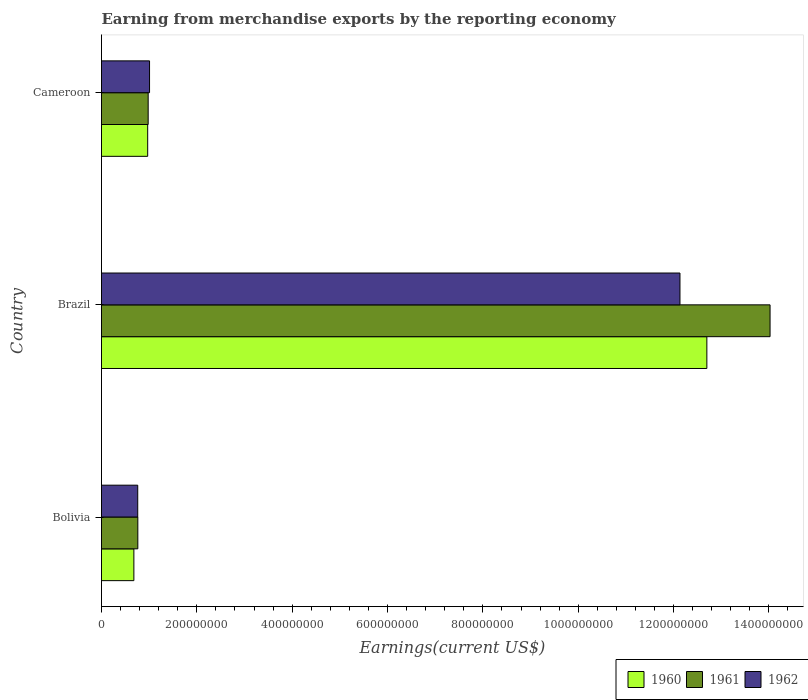How many different coloured bars are there?
Ensure brevity in your answer.  3. Are the number of bars on each tick of the Y-axis equal?
Offer a very short reply. Yes. How many bars are there on the 1st tick from the top?
Your answer should be compact. 3. What is the amount earned from merchandise exports in 1960 in Brazil?
Offer a very short reply. 1.27e+09. Across all countries, what is the maximum amount earned from merchandise exports in 1962?
Your response must be concise. 1.21e+09. Across all countries, what is the minimum amount earned from merchandise exports in 1962?
Give a very brief answer. 7.60e+07. What is the total amount earned from merchandise exports in 1961 in the graph?
Make the answer very short. 1.58e+09. What is the difference between the amount earned from merchandise exports in 1961 in Bolivia and that in Cameroon?
Your answer should be compact. -2.17e+07. What is the difference between the amount earned from merchandise exports in 1962 in Bolivia and the amount earned from merchandise exports in 1960 in Brazil?
Keep it short and to the point. -1.19e+09. What is the average amount earned from merchandise exports in 1960 per country?
Keep it short and to the point. 4.78e+08. What is the difference between the amount earned from merchandise exports in 1961 and amount earned from merchandise exports in 1960 in Brazil?
Keep it short and to the point. 1.33e+08. In how many countries, is the amount earned from merchandise exports in 1961 greater than 120000000 US$?
Offer a terse response. 1. What is the ratio of the amount earned from merchandise exports in 1960 in Brazil to that in Cameroon?
Keep it short and to the point. 13.11. Is the difference between the amount earned from merchandise exports in 1961 in Brazil and Cameroon greater than the difference between the amount earned from merchandise exports in 1960 in Brazil and Cameroon?
Provide a short and direct response. Yes. What is the difference between the highest and the second highest amount earned from merchandise exports in 1961?
Make the answer very short. 1.30e+09. What is the difference between the highest and the lowest amount earned from merchandise exports in 1961?
Provide a short and direct response. 1.33e+09. What does the 1st bar from the bottom in Bolivia represents?
Your answer should be compact. 1960. Is it the case that in every country, the sum of the amount earned from merchandise exports in 1960 and amount earned from merchandise exports in 1961 is greater than the amount earned from merchandise exports in 1962?
Offer a very short reply. Yes. Are the values on the major ticks of X-axis written in scientific E-notation?
Provide a short and direct response. No. Does the graph contain grids?
Ensure brevity in your answer.  No. Where does the legend appear in the graph?
Your response must be concise. Bottom right. How many legend labels are there?
Your response must be concise. 3. What is the title of the graph?
Ensure brevity in your answer.  Earning from merchandise exports by the reporting economy. What is the label or title of the X-axis?
Provide a succinct answer. Earnings(current US$). What is the label or title of the Y-axis?
Provide a succinct answer. Country. What is the Earnings(current US$) in 1960 in Bolivia?
Make the answer very short. 6.79e+07. What is the Earnings(current US$) of 1961 in Bolivia?
Keep it short and to the point. 7.62e+07. What is the Earnings(current US$) in 1962 in Bolivia?
Ensure brevity in your answer.  7.60e+07. What is the Earnings(current US$) of 1960 in Brazil?
Ensure brevity in your answer.  1.27e+09. What is the Earnings(current US$) in 1961 in Brazil?
Offer a very short reply. 1.40e+09. What is the Earnings(current US$) in 1962 in Brazil?
Offer a terse response. 1.21e+09. What is the Earnings(current US$) in 1960 in Cameroon?
Make the answer very short. 9.69e+07. What is the Earnings(current US$) in 1961 in Cameroon?
Your answer should be very brief. 9.79e+07. What is the Earnings(current US$) of 1962 in Cameroon?
Offer a terse response. 1.01e+08. Across all countries, what is the maximum Earnings(current US$) of 1960?
Your answer should be very brief. 1.27e+09. Across all countries, what is the maximum Earnings(current US$) of 1961?
Your answer should be compact. 1.40e+09. Across all countries, what is the maximum Earnings(current US$) in 1962?
Offer a very short reply. 1.21e+09. Across all countries, what is the minimum Earnings(current US$) in 1960?
Keep it short and to the point. 6.79e+07. Across all countries, what is the minimum Earnings(current US$) of 1961?
Ensure brevity in your answer.  7.62e+07. Across all countries, what is the minimum Earnings(current US$) in 1962?
Provide a succinct answer. 7.60e+07. What is the total Earnings(current US$) in 1960 in the graph?
Your answer should be very brief. 1.43e+09. What is the total Earnings(current US$) of 1961 in the graph?
Keep it short and to the point. 1.58e+09. What is the total Earnings(current US$) of 1962 in the graph?
Your answer should be very brief. 1.39e+09. What is the difference between the Earnings(current US$) of 1960 in Bolivia and that in Brazil?
Offer a terse response. -1.20e+09. What is the difference between the Earnings(current US$) in 1961 in Bolivia and that in Brazil?
Give a very brief answer. -1.33e+09. What is the difference between the Earnings(current US$) in 1962 in Bolivia and that in Brazil?
Your response must be concise. -1.14e+09. What is the difference between the Earnings(current US$) of 1960 in Bolivia and that in Cameroon?
Make the answer very short. -2.90e+07. What is the difference between the Earnings(current US$) of 1961 in Bolivia and that in Cameroon?
Give a very brief answer. -2.17e+07. What is the difference between the Earnings(current US$) of 1962 in Bolivia and that in Cameroon?
Your answer should be compact. -2.48e+07. What is the difference between the Earnings(current US$) in 1960 in Brazil and that in Cameroon?
Give a very brief answer. 1.17e+09. What is the difference between the Earnings(current US$) in 1961 in Brazil and that in Cameroon?
Your answer should be compact. 1.30e+09. What is the difference between the Earnings(current US$) of 1962 in Brazil and that in Cameroon?
Offer a very short reply. 1.11e+09. What is the difference between the Earnings(current US$) in 1960 in Bolivia and the Earnings(current US$) in 1961 in Brazil?
Ensure brevity in your answer.  -1.33e+09. What is the difference between the Earnings(current US$) in 1960 in Bolivia and the Earnings(current US$) in 1962 in Brazil?
Your response must be concise. -1.15e+09. What is the difference between the Earnings(current US$) of 1961 in Bolivia and the Earnings(current US$) of 1962 in Brazil?
Offer a very short reply. -1.14e+09. What is the difference between the Earnings(current US$) in 1960 in Bolivia and the Earnings(current US$) in 1961 in Cameroon?
Provide a short and direct response. -3.00e+07. What is the difference between the Earnings(current US$) in 1960 in Bolivia and the Earnings(current US$) in 1962 in Cameroon?
Make the answer very short. -3.29e+07. What is the difference between the Earnings(current US$) of 1961 in Bolivia and the Earnings(current US$) of 1962 in Cameroon?
Offer a very short reply. -2.46e+07. What is the difference between the Earnings(current US$) in 1960 in Brazil and the Earnings(current US$) in 1961 in Cameroon?
Keep it short and to the point. 1.17e+09. What is the difference between the Earnings(current US$) in 1960 in Brazil and the Earnings(current US$) in 1962 in Cameroon?
Your response must be concise. 1.17e+09. What is the difference between the Earnings(current US$) in 1961 in Brazil and the Earnings(current US$) in 1962 in Cameroon?
Provide a succinct answer. 1.30e+09. What is the average Earnings(current US$) of 1960 per country?
Your response must be concise. 4.78e+08. What is the average Earnings(current US$) in 1961 per country?
Your answer should be compact. 5.26e+08. What is the average Earnings(current US$) of 1962 per country?
Your answer should be compact. 4.63e+08. What is the difference between the Earnings(current US$) in 1960 and Earnings(current US$) in 1961 in Bolivia?
Provide a succinct answer. -8.30e+06. What is the difference between the Earnings(current US$) of 1960 and Earnings(current US$) of 1962 in Bolivia?
Offer a terse response. -8.10e+06. What is the difference between the Earnings(current US$) of 1961 and Earnings(current US$) of 1962 in Bolivia?
Your answer should be compact. 2.00e+05. What is the difference between the Earnings(current US$) of 1960 and Earnings(current US$) of 1961 in Brazil?
Offer a terse response. -1.33e+08. What is the difference between the Earnings(current US$) of 1960 and Earnings(current US$) of 1962 in Brazil?
Give a very brief answer. 5.64e+07. What is the difference between the Earnings(current US$) of 1961 and Earnings(current US$) of 1962 in Brazil?
Ensure brevity in your answer.  1.89e+08. What is the difference between the Earnings(current US$) in 1960 and Earnings(current US$) in 1962 in Cameroon?
Give a very brief answer. -3.90e+06. What is the difference between the Earnings(current US$) of 1961 and Earnings(current US$) of 1962 in Cameroon?
Make the answer very short. -2.90e+06. What is the ratio of the Earnings(current US$) in 1960 in Bolivia to that in Brazil?
Offer a terse response. 0.05. What is the ratio of the Earnings(current US$) of 1961 in Bolivia to that in Brazil?
Make the answer very short. 0.05. What is the ratio of the Earnings(current US$) in 1962 in Bolivia to that in Brazil?
Offer a very short reply. 0.06. What is the ratio of the Earnings(current US$) of 1960 in Bolivia to that in Cameroon?
Your answer should be very brief. 0.7. What is the ratio of the Earnings(current US$) in 1961 in Bolivia to that in Cameroon?
Your response must be concise. 0.78. What is the ratio of the Earnings(current US$) of 1962 in Bolivia to that in Cameroon?
Your answer should be very brief. 0.75. What is the ratio of the Earnings(current US$) in 1960 in Brazil to that in Cameroon?
Provide a short and direct response. 13.11. What is the ratio of the Earnings(current US$) of 1961 in Brazil to that in Cameroon?
Give a very brief answer. 14.33. What is the ratio of the Earnings(current US$) in 1962 in Brazil to that in Cameroon?
Your answer should be very brief. 12.04. What is the difference between the highest and the second highest Earnings(current US$) in 1960?
Ensure brevity in your answer.  1.17e+09. What is the difference between the highest and the second highest Earnings(current US$) of 1961?
Provide a short and direct response. 1.30e+09. What is the difference between the highest and the second highest Earnings(current US$) in 1962?
Provide a succinct answer. 1.11e+09. What is the difference between the highest and the lowest Earnings(current US$) in 1960?
Give a very brief answer. 1.20e+09. What is the difference between the highest and the lowest Earnings(current US$) in 1961?
Your answer should be very brief. 1.33e+09. What is the difference between the highest and the lowest Earnings(current US$) of 1962?
Your answer should be very brief. 1.14e+09. 